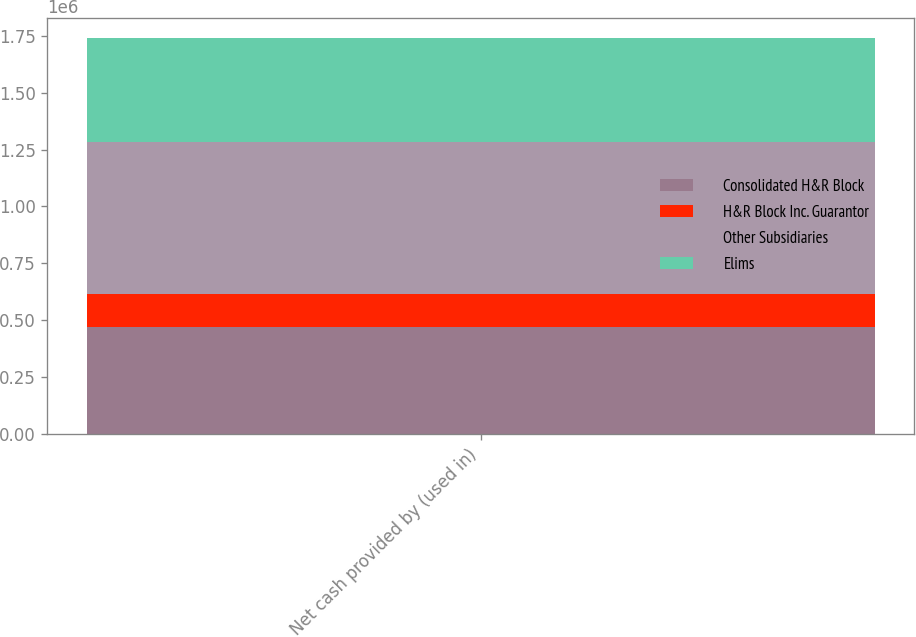Convert chart to OTSL. <chart><loc_0><loc_0><loc_500><loc_500><stacked_bar_chart><ecel><fcel>Net cash provided by (used in)<nl><fcel>Consolidated H&R Block<fcel>469438<nl><fcel>H&R Block Inc. Guarantor<fcel>144731<nl><fcel>Other Subsidiaries<fcel>669500<nl><fcel>Elims<fcel>459816<nl></chart> 